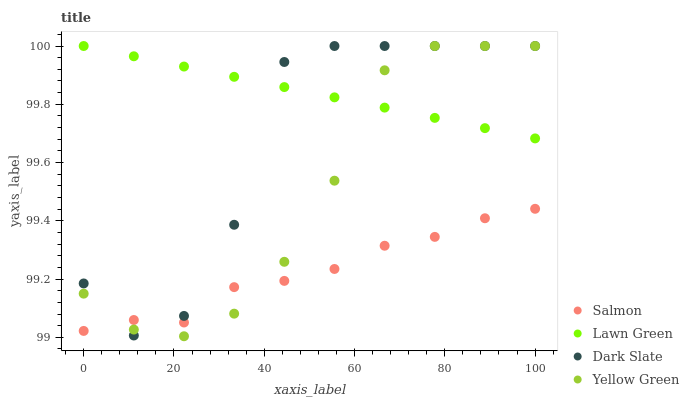Does Salmon have the minimum area under the curve?
Answer yes or no. Yes. Does Lawn Green have the maximum area under the curve?
Answer yes or no. Yes. Does Yellow Green have the minimum area under the curve?
Answer yes or no. No. Does Yellow Green have the maximum area under the curve?
Answer yes or no. No. Is Lawn Green the smoothest?
Answer yes or no. Yes. Is Dark Slate the roughest?
Answer yes or no. Yes. Is Salmon the smoothest?
Answer yes or no. No. Is Salmon the roughest?
Answer yes or no. No. Does Yellow Green have the lowest value?
Answer yes or no. Yes. Does Salmon have the lowest value?
Answer yes or no. No. Does Dark Slate have the highest value?
Answer yes or no. Yes. Does Salmon have the highest value?
Answer yes or no. No. Is Salmon less than Lawn Green?
Answer yes or no. Yes. Is Lawn Green greater than Salmon?
Answer yes or no. Yes. Does Yellow Green intersect Dark Slate?
Answer yes or no. Yes. Is Yellow Green less than Dark Slate?
Answer yes or no. No. Is Yellow Green greater than Dark Slate?
Answer yes or no. No. Does Salmon intersect Lawn Green?
Answer yes or no. No. 